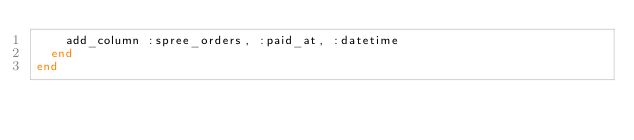<code> <loc_0><loc_0><loc_500><loc_500><_Ruby_>    add_column :spree_orders, :paid_at, :datetime
  end
end
</code> 